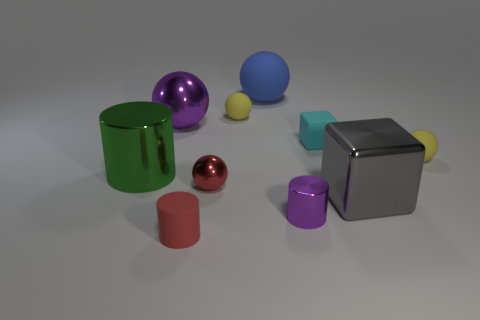There is a red object right of the red rubber thing; is there a big purple sphere that is on the right side of it?
Your response must be concise. No. The purple thing on the left side of the tiny matte cylinder has what shape?
Keep it short and to the point. Sphere. There is a object that is the same color as the small shiny ball; what material is it?
Ensure brevity in your answer.  Rubber. There is a tiny rubber ball that is on the right side of the small yellow matte object that is on the left side of the small purple shiny object; what is its color?
Your answer should be very brief. Yellow. Is the green metallic cylinder the same size as the cyan matte thing?
Ensure brevity in your answer.  No. There is another object that is the same shape as the large gray metallic thing; what is its material?
Your answer should be very brief. Rubber. What number of blue rubber objects have the same size as the shiny cube?
Make the answer very short. 1. There is a large thing that is the same material as the small cube; what color is it?
Offer a terse response. Blue. Are there fewer big blue rubber balls than tiny cylinders?
Ensure brevity in your answer.  Yes. How many cyan things are big spheres or cubes?
Give a very brief answer. 1. 